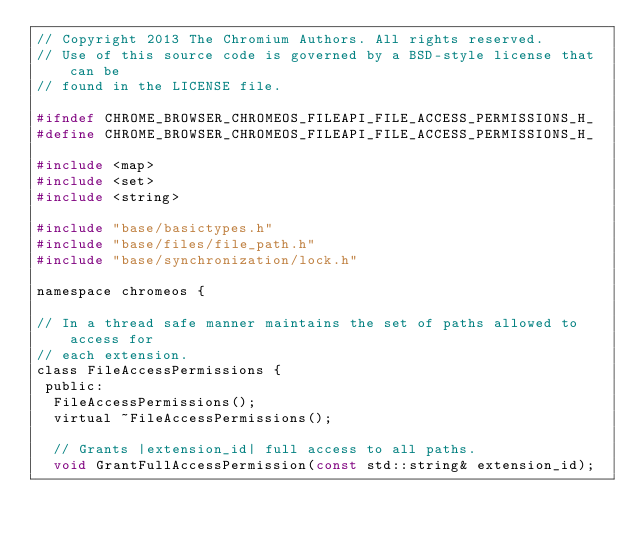Convert code to text. <code><loc_0><loc_0><loc_500><loc_500><_C_>// Copyright 2013 The Chromium Authors. All rights reserved.
// Use of this source code is governed by a BSD-style license that can be
// found in the LICENSE file.

#ifndef CHROME_BROWSER_CHROMEOS_FILEAPI_FILE_ACCESS_PERMISSIONS_H_
#define CHROME_BROWSER_CHROMEOS_FILEAPI_FILE_ACCESS_PERMISSIONS_H_

#include <map>
#include <set>
#include <string>

#include "base/basictypes.h"
#include "base/files/file_path.h"
#include "base/synchronization/lock.h"

namespace chromeos {

// In a thread safe manner maintains the set of paths allowed to access for
// each extension.
class FileAccessPermissions {
 public:
  FileAccessPermissions();
  virtual ~FileAccessPermissions();

  // Grants |extension_id| full access to all paths.
  void GrantFullAccessPermission(const std::string& extension_id);</code> 